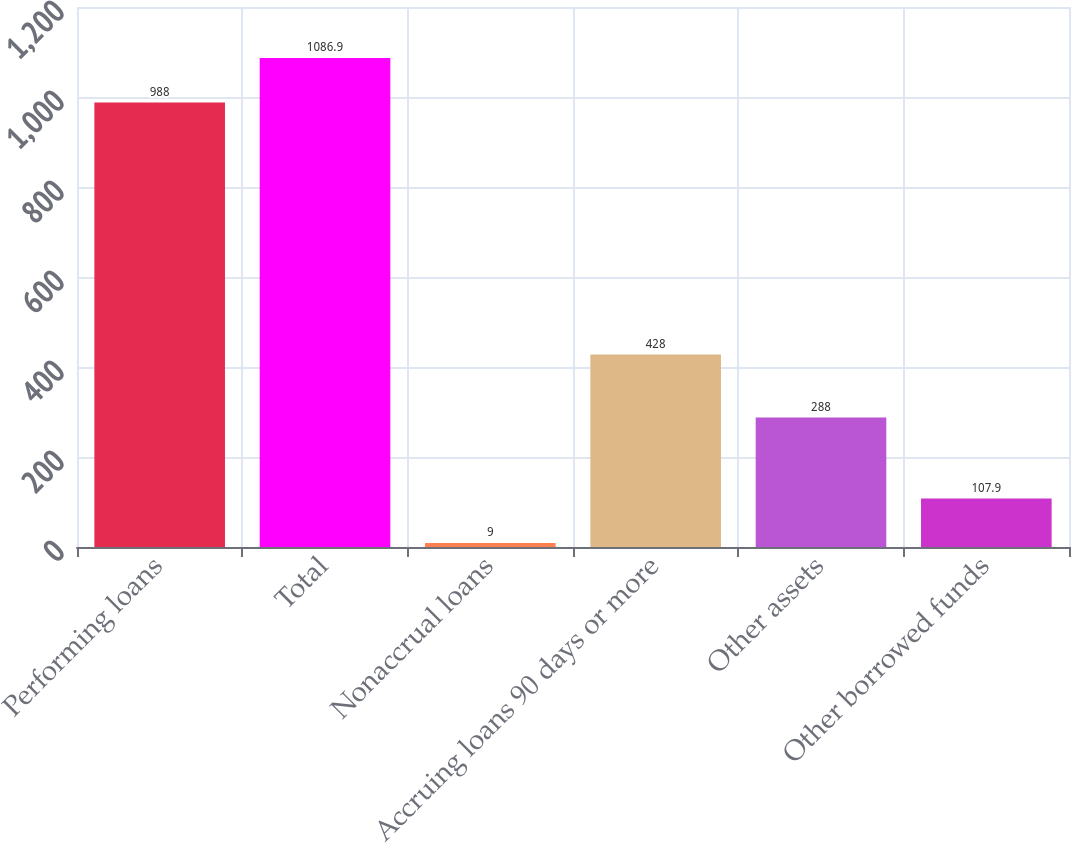Convert chart. <chart><loc_0><loc_0><loc_500><loc_500><bar_chart><fcel>Performing loans<fcel>Total<fcel>Nonaccrual loans<fcel>Accruing loans 90 days or more<fcel>Other assets<fcel>Other borrowed funds<nl><fcel>988<fcel>1086.9<fcel>9<fcel>428<fcel>288<fcel>107.9<nl></chart> 